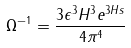Convert formula to latex. <formula><loc_0><loc_0><loc_500><loc_500>\Omega ^ { - 1 } = \frac { 3 \epsilon ^ { 3 } H ^ { 3 } e ^ { 3 H s } } { 4 \pi ^ { 4 } }</formula> 